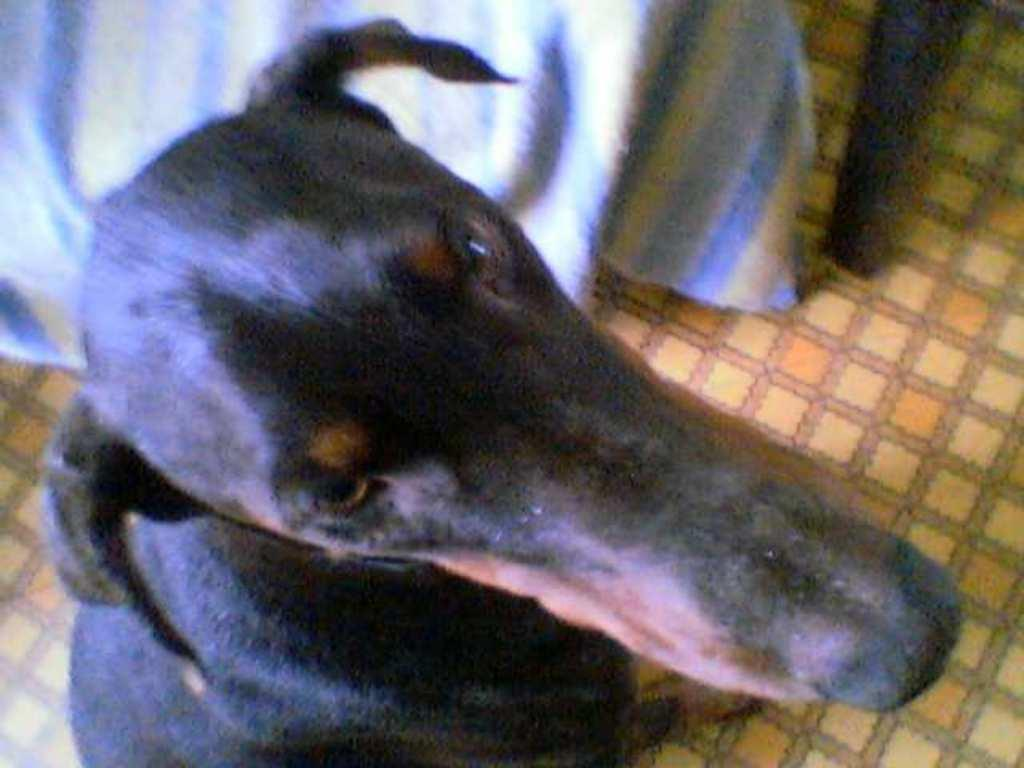What is the main subject in the center of the image? There is a dog in the center of the image. Where is the dog located in the image? The dog is on the floor. What colors can be seen on the dog's fur? The dog has black and brown coloring. What can be seen at the top of the image? There is a cloth and a wooden object visible at the top of the image. What type of bun is the dog eating in the image? There is no bun present in the image; the dog is on the floor with black and brown coloring. How many bikes are visible in the image? There are no bikes present in the image. 